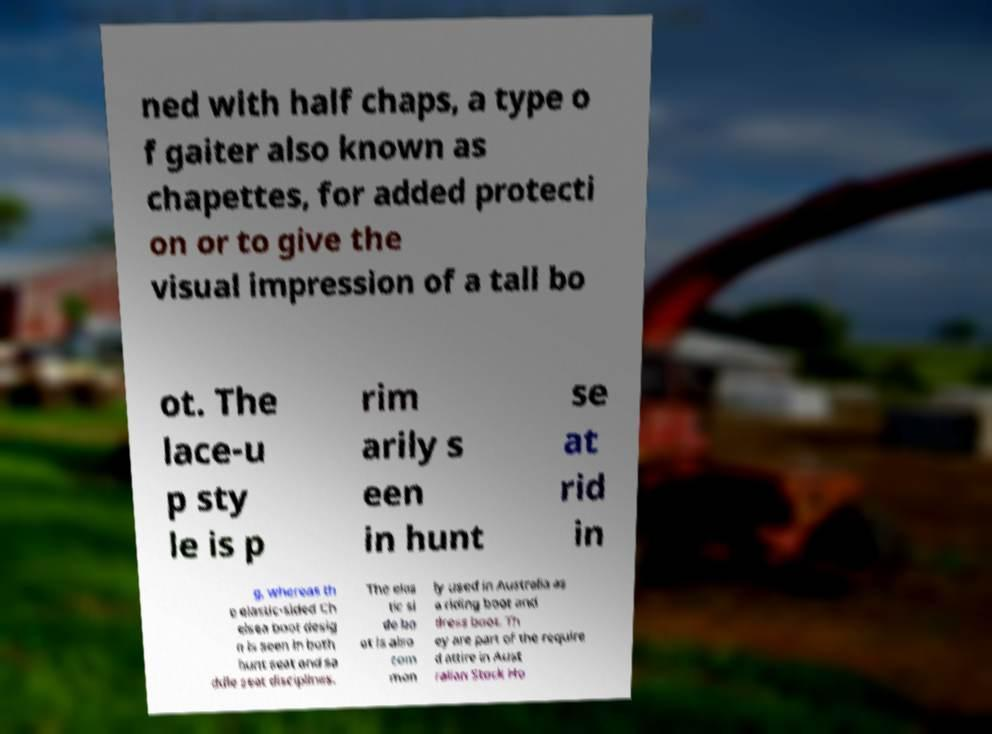Can you accurately transcribe the text from the provided image for me? ned with half chaps, a type o f gaiter also known as chapettes, for added protecti on or to give the visual impression of a tall bo ot. The lace-u p sty le is p rim arily s een in hunt se at rid in g, whereas th e elastic-sided Ch elsea boot desig n is seen in both hunt seat and sa ddle seat disciplines. The elas tic si de bo ot is also com mon ly used in Australia as a riding boot and dress boot. Th ey are part of the require d attire in Aust ralian Stock Ho 